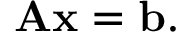Convert formula to latex. <formula><loc_0><loc_0><loc_500><loc_500>A x = b .</formula> 